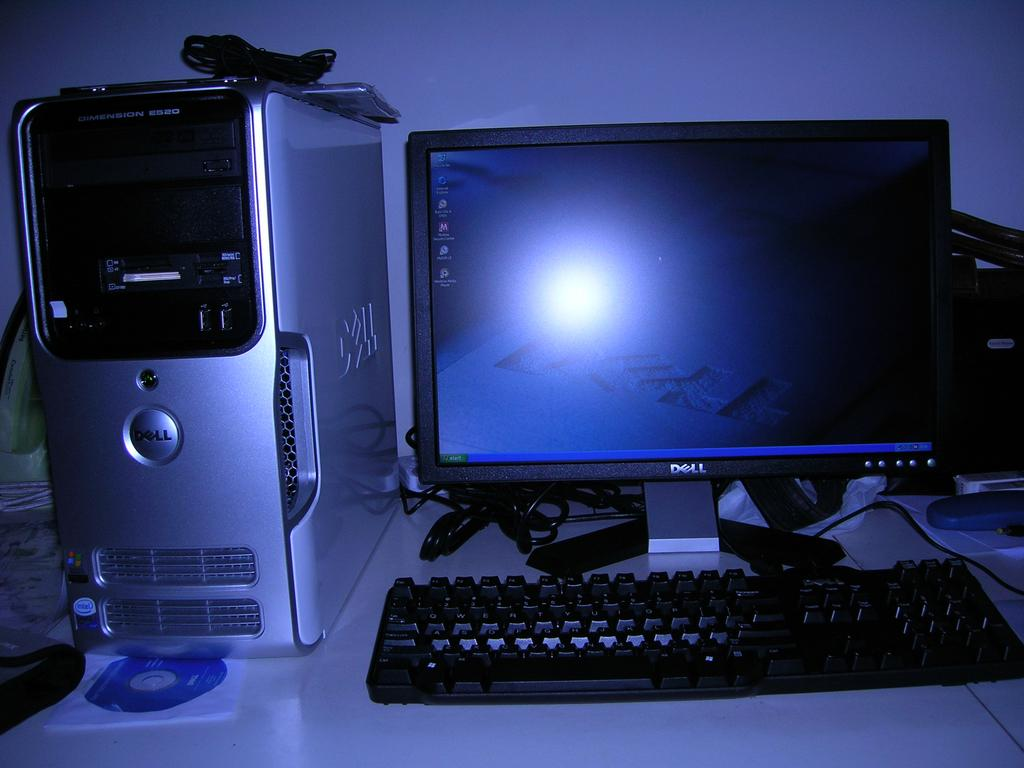<image>
Write a terse but informative summary of the picture. the word Dell is on the computer screen 